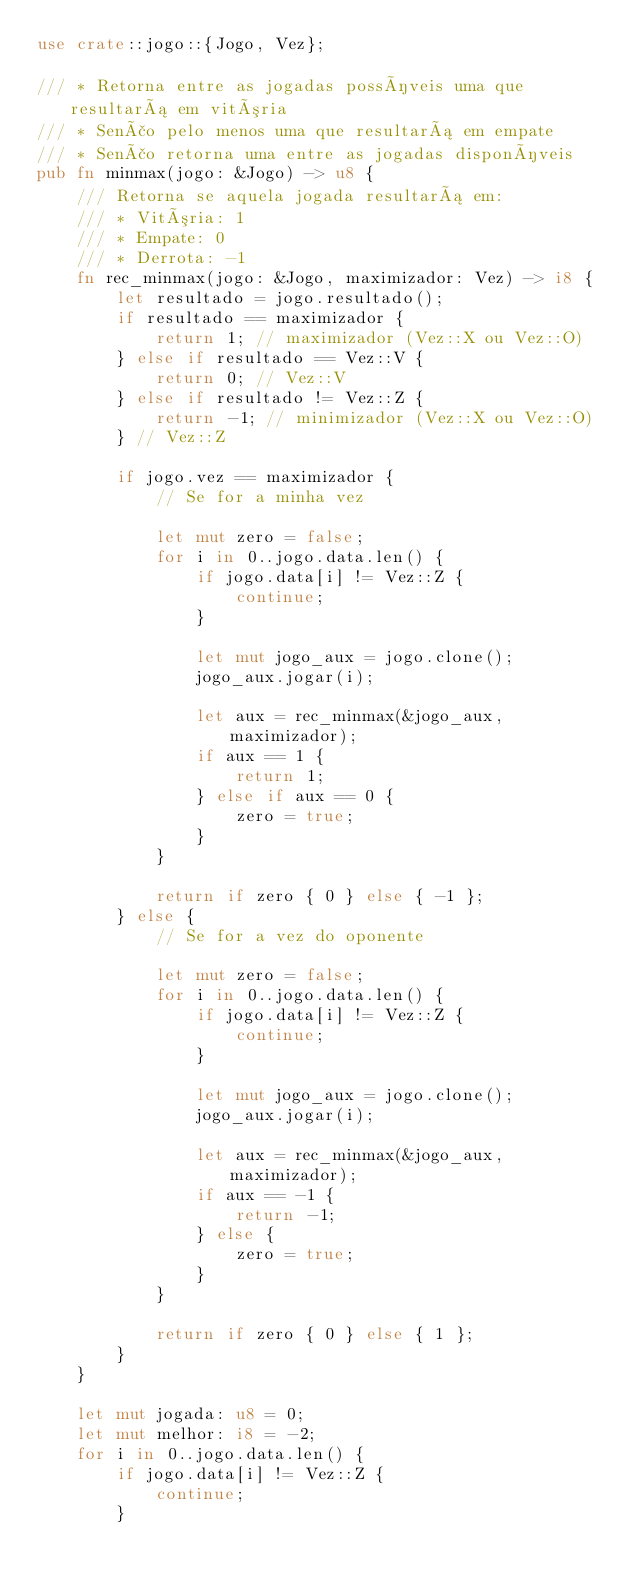<code> <loc_0><loc_0><loc_500><loc_500><_Rust_>use crate::jogo::{Jogo, Vez};

/// * Retorna entre as jogadas possíveis uma que resultará em vitória
/// * Senão pelo menos uma que resultará em empate
/// * Senão retorna uma entre as jogadas disponíveis
pub fn minmax(jogo: &Jogo) -> u8 {
    /// Retorna se aquela jogada resultará em:
    /// * Vitória: 1
    /// * Empate: 0
    /// * Derrota: -1
    fn rec_minmax(jogo: &Jogo, maximizador: Vez) -> i8 {
        let resultado = jogo.resultado();
        if resultado == maximizador {
            return 1; // maximizador (Vez::X ou Vez::O)
        } else if resultado == Vez::V {
            return 0; // Vez::V
        } else if resultado != Vez::Z {
            return -1; // minimizador (Vez::X ou Vez::O)
        } // Vez::Z

        if jogo.vez == maximizador {
            // Se for a minha vez

            let mut zero = false;
            for i in 0..jogo.data.len() {
                if jogo.data[i] != Vez::Z {
                    continue;
                }

                let mut jogo_aux = jogo.clone();
                jogo_aux.jogar(i);

                let aux = rec_minmax(&jogo_aux, maximizador);
                if aux == 1 {
                    return 1;
                } else if aux == 0 {
                    zero = true;
                }
            }

            return if zero { 0 } else { -1 };
        } else {
            // Se for a vez do oponente

            let mut zero = false;
            for i in 0..jogo.data.len() {
                if jogo.data[i] != Vez::Z {
                    continue;
                }

                let mut jogo_aux = jogo.clone();
                jogo_aux.jogar(i);

                let aux = rec_minmax(&jogo_aux, maximizador);
                if aux == -1 {
                    return -1;
                } else {
                    zero = true;
                }
            }

            return if zero { 0 } else { 1 };
        }
    }

    let mut jogada: u8 = 0;
    let mut melhor: i8 = -2;
    for i in 0..jogo.data.len() {
        if jogo.data[i] != Vez::Z {
            continue;
        }
</code> 